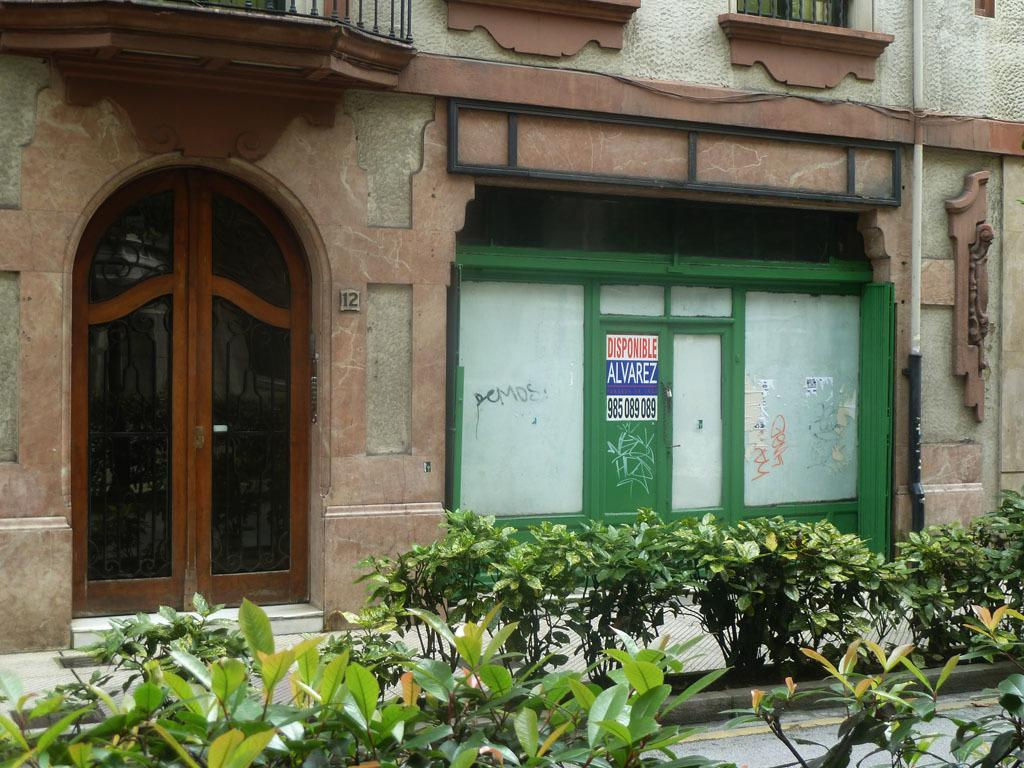What type of structure is visible in the image? There is a building in the image. Where is the door located on the building? The door is on the left side of the building. What else can be seen on the road in the image? There are plants on the road in the image. How many leaves can be seen on the toad in the image? There is no toad present in the image, and therefore no leaves can be seen on it. 